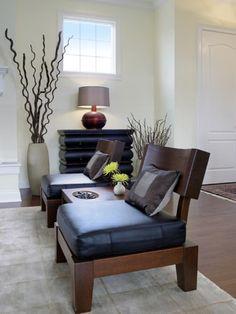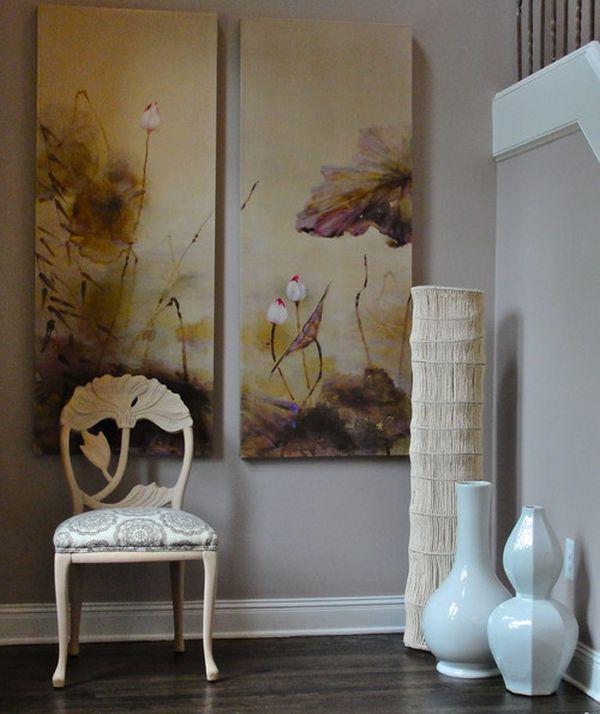The first image is the image on the left, the second image is the image on the right. Evaluate the accuracy of this statement regarding the images: "There are empty vases on a shelf in the image on the left.". Is it true? Answer yes or no. No. The first image is the image on the left, the second image is the image on the right. For the images displayed, is the sentence "Each image includes at least one vase that holds branches that extend upward instead of drooping leaves and includes at least one vase that sits on the floor." factually correct? Answer yes or no. No. 